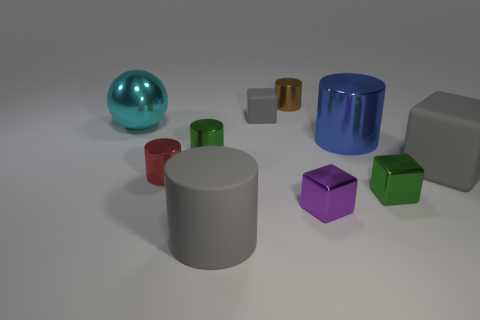How many other tiny brown objects have the same shape as the brown shiny thing?
Provide a short and direct response. 0. What number of cyan objects are either large things or small shiny spheres?
Your response must be concise. 1. How big is the rubber block that is in front of the big metal thing that is to the left of the purple shiny thing?
Your response must be concise. Large. There is a brown object that is the same shape as the small red object; what is it made of?
Keep it short and to the point. Metal. What number of gray matte cylinders are the same size as the purple shiny object?
Give a very brief answer. 0. Does the red cylinder have the same size as the blue cylinder?
Make the answer very short. No. What size is the cylinder that is in front of the green shiny cylinder and on the right side of the red thing?
Make the answer very short. Large. Are there more cubes that are on the left side of the small purple metallic block than blocks behind the tiny rubber cube?
Give a very brief answer. Yes. The rubber thing that is the same shape as the blue metallic object is what color?
Offer a terse response. Gray. Do the rubber thing in front of the small purple shiny object and the tiny matte thing have the same color?
Give a very brief answer. Yes. 